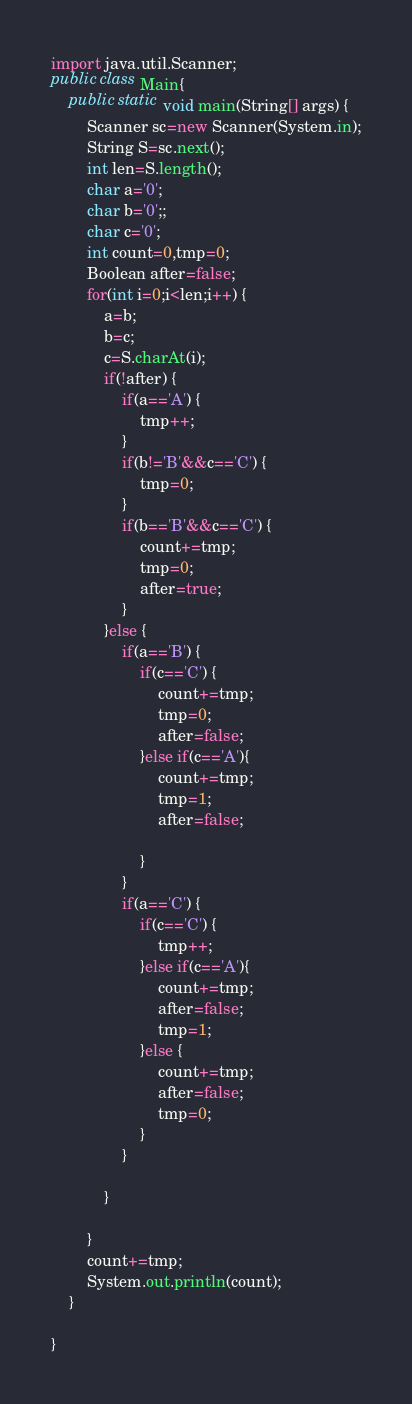Convert code to text. <code><loc_0><loc_0><loc_500><loc_500><_Java_>import java.util.Scanner;
public class Main{
	public static void main(String[] args) {
		Scanner sc=new Scanner(System.in);
		String S=sc.next();
		int len=S.length();
		char a='0';
		char b='0';;
		char c='0';
		int count=0,tmp=0;
		Boolean after=false;
		for(int i=0;i<len;i++) {
			a=b;
			b=c;
			c=S.charAt(i);
			if(!after) {
				if(a=='A') {
					tmp++;
				}
				if(b!='B'&&c=='C') {
					tmp=0;
				}
				if(b=='B'&&c=='C') {
					count+=tmp;
					tmp=0;
					after=true;
				}
			}else {
				if(a=='B') {
					if(c=='C') {
						count+=tmp;
						tmp=0;
						after=false;
					}else if(c=='A'){
						count+=tmp;
						tmp=1;
						after=false;

					}
				}
				if(a=='C') {
					if(c=='C') {
						tmp++;
					}else if(c=='A'){
						count+=tmp;
						after=false;
						tmp=1;
					}else {
						count+=tmp;
						after=false;
						tmp=0;
					}
				}

			}

		}
		count+=tmp;
		System.out.println(count);
	}

}
</code> 